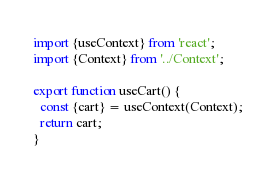Convert code to text. <code><loc_0><loc_0><loc_500><loc_500><_TypeScript_>import {useContext} from 'react';
import {Context} from '../Context';

export function useCart() {
  const {cart} = useContext(Context);
  return cart;
}
</code> 